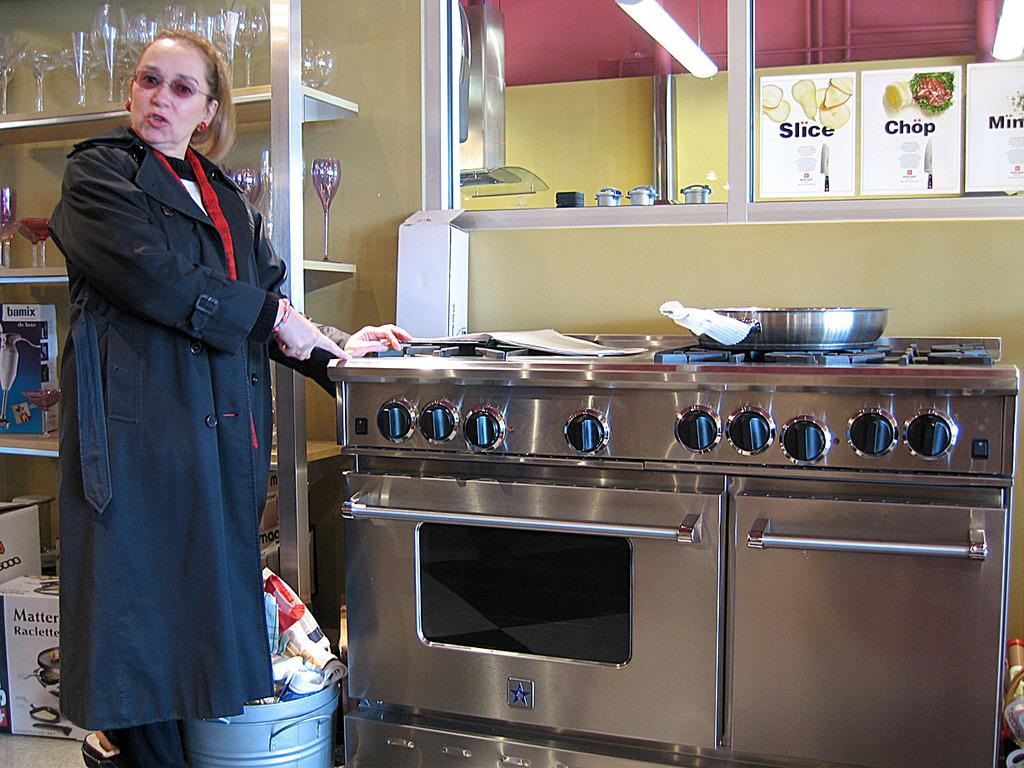<image>
Give a short and clear explanation of the subsequent image. a lady with a slice sign on the other side of the window 